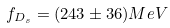Convert formula to latex. <formula><loc_0><loc_0><loc_500><loc_500>f _ { D _ { s } } = ( 2 4 3 \pm 3 6 ) M e V</formula> 